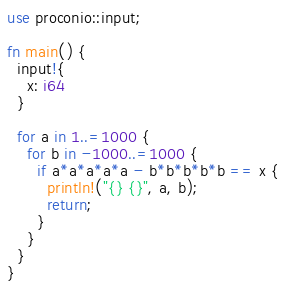Convert code to text. <code><loc_0><loc_0><loc_500><loc_500><_Rust_>use proconio::input;

fn main() {
  input!{
    x: i64
  }
  
  for a in 1..=1000 {
    for b in -1000..=1000 {
      if a*a*a*a*a - b*b*b*b*b == x {
        println!("{} {}", a, b);
        return;
      }
    }
  }
}</code> 